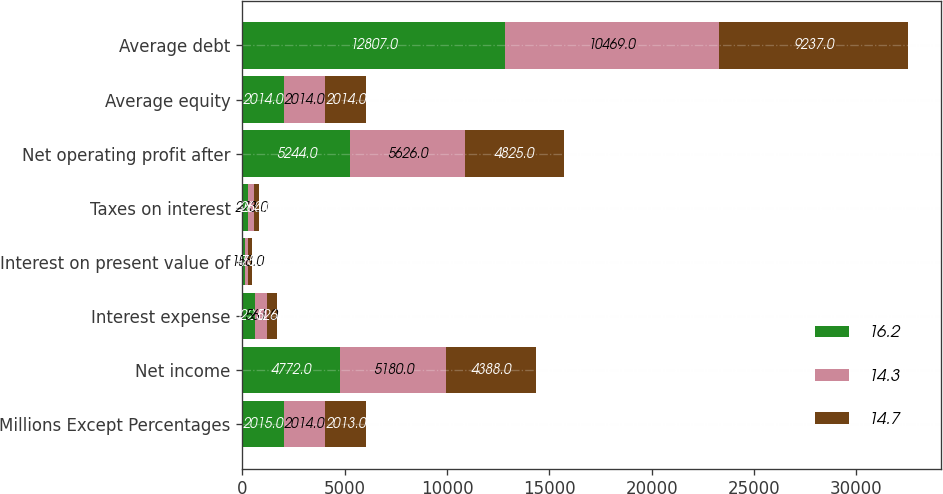Convert chart to OTSL. <chart><loc_0><loc_0><loc_500><loc_500><stacked_bar_chart><ecel><fcel>Millions Except Percentages<fcel>Net income<fcel>Interest expense<fcel>Interest on present value of<fcel>Taxes on interest<fcel>Net operating profit after<fcel>Average equity<fcel>Average debt<nl><fcel>16.2<fcel>2015<fcel>4772<fcel>622<fcel>135<fcel>285<fcel>5244<fcel>2014<fcel>12807<nl><fcel>14.3<fcel>2014<fcel>5180<fcel>561<fcel>158<fcel>273<fcel>5626<fcel>2014<fcel>10469<nl><fcel>14.7<fcel>2013<fcel>4388<fcel>526<fcel>175<fcel>264<fcel>4825<fcel>2014<fcel>9237<nl></chart> 